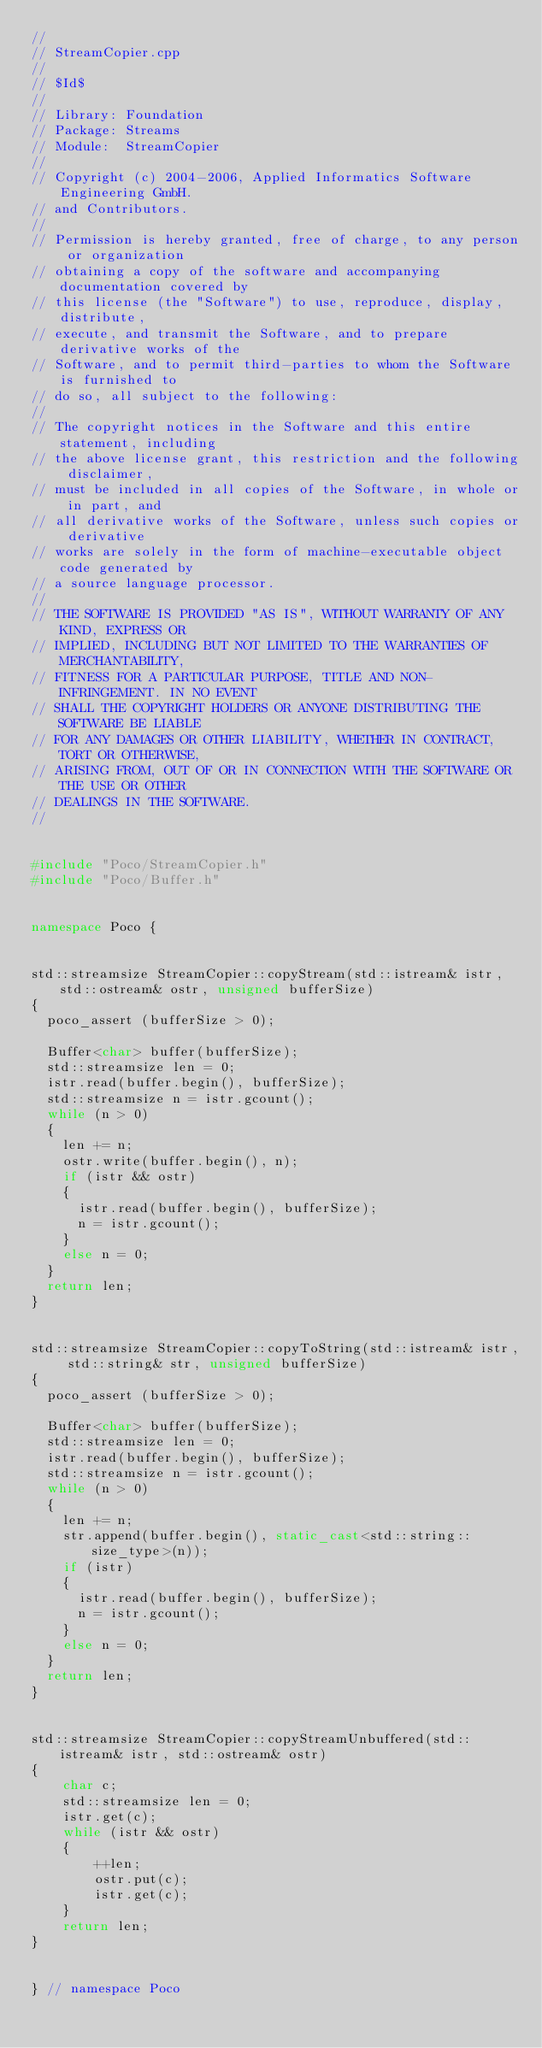<code> <loc_0><loc_0><loc_500><loc_500><_C++_>//
// StreamCopier.cpp
//
// $Id$
//
// Library: Foundation
// Package: Streams
// Module:  StreamCopier
//
// Copyright (c) 2004-2006, Applied Informatics Software Engineering GmbH.
// and Contributors.
//
// Permission is hereby granted, free of charge, to any person or organization
// obtaining a copy of the software and accompanying documentation covered by
// this license (the "Software") to use, reproduce, display, distribute,
// execute, and transmit the Software, and to prepare derivative works of the
// Software, and to permit third-parties to whom the Software is furnished to
// do so, all subject to the following:
// 
// The copyright notices in the Software and this entire statement, including
// the above license grant, this restriction and the following disclaimer,
// must be included in all copies of the Software, in whole or in part, and
// all derivative works of the Software, unless such copies or derivative
// works are solely in the form of machine-executable object code generated by
// a source language processor.
// 
// THE SOFTWARE IS PROVIDED "AS IS", WITHOUT WARRANTY OF ANY KIND, EXPRESS OR
// IMPLIED, INCLUDING BUT NOT LIMITED TO THE WARRANTIES OF MERCHANTABILITY,
// FITNESS FOR A PARTICULAR PURPOSE, TITLE AND NON-INFRINGEMENT. IN NO EVENT
// SHALL THE COPYRIGHT HOLDERS OR ANYONE DISTRIBUTING THE SOFTWARE BE LIABLE
// FOR ANY DAMAGES OR OTHER LIABILITY, WHETHER IN CONTRACT, TORT OR OTHERWISE,
// ARISING FROM, OUT OF OR IN CONNECTION WITH THE SOFTWARE OR THE USE OR OTHER
// DEALINGS IN THE SOFTWARE.
//


#include "Poco/StreamCopier.h"
#include "Poco/Buffer.h"


namespace Poco {


std::streamsize StreamCopier::copyStream(std::istream& istr, std::ostream& ostr, unsigned bufferSize)
{
	poco_assert (bufferSize > 0);

	Buffer<char> buffer(bufferSize);
	std::streamsize len = 0;
	istr.read(buffer.begin(), bufferSize);
	std::streamsize n = istr.gcount();
	while (n > 0)
	{
		len += n;
		ostr.write(buffer.begin(), n);
		if (istr && ostr)
		{
			istr.read(buffer.begin(), bufferSize);
			n = istr.gcount();
		}
		else n = 0;
	}
	return len;
}


std::streamsize StreamCopier::copyToString(std::istream& istr, std::string& str, unsigned bufferSize)
{
	poco_assert (bufferSize > 0);

	Buffer<char> buffer(bufferSize);
	std::streamsize len = 0;
	istr.read(buffer.begin(), bufferSize);
	std::streamsize n = istr.gcount();
	while (n > 0)
	{
		len += n;
		str.append(buffer.begin(), static_cast<std::string::size_type>(n));
		if (istr)
		{
			istr.read(buffer.begin(), bufferSize);
			n = istr.gcount();
		}
		else n = 0;
	}
	return len;
}


std::streamsize StreamCopier::copyStreamUnbuffered(std::istream& istr, std::ostream& ostr)
{
    char c;
    std::streamsize len = 0;
    istr.get(c);
    while (istr && ostr)
    {
        ++len;
        ostr.put(c);
        istr.get(c);
    }
    return len;
}


} // namespace Poco
</code> 